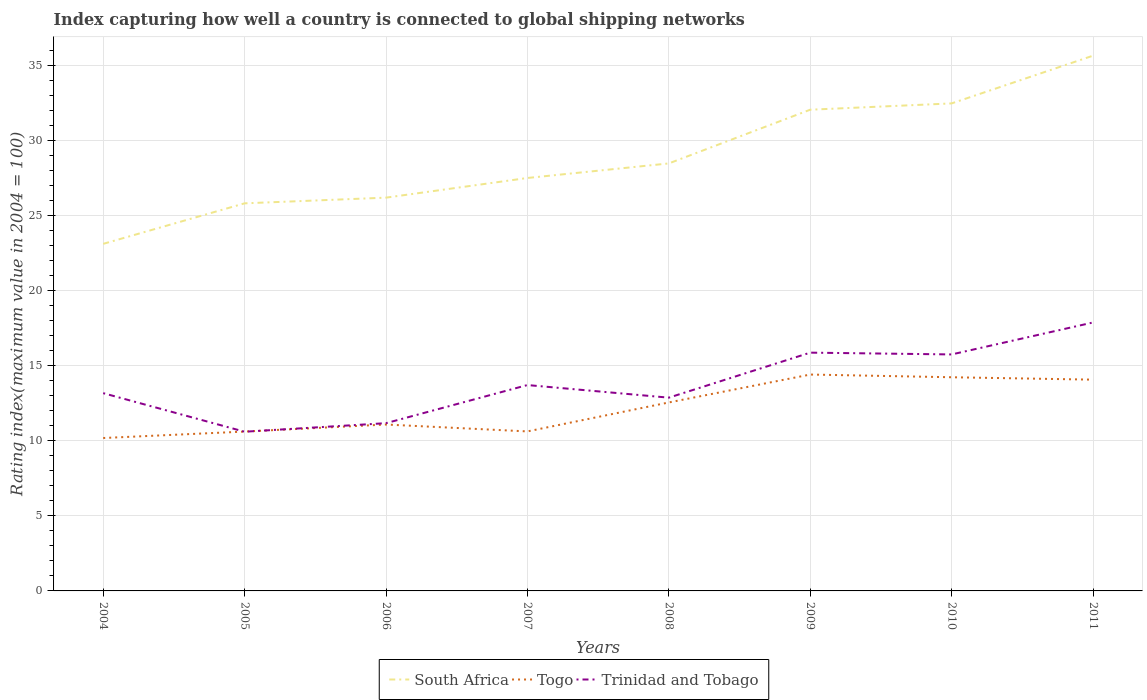How many different coloured lines are there?
Provide a short and direct response. 3. Does the line corresponding to South Africa intersect with the line corresponding to Togo?
Make the answer very short. No. Is the number of lines equal to the number of legend labels?
Your answer should be very brief. Yes. Across all years, what is the maximum rating index in Trinidad and Tobago?
Your response must be concise. 10.61. In which year was the rating index in Togo maximum?
Keep it short and to the point. 2004. What is the total rating index in South Africa in the graph?
Your response must be concise. -4.97. What is the difference between the highest and the second highest rating index in South Africa?
Your response must be concise. 12.54. Is the rating index in Trinidad and Tobago strictly greater than the rating index in Togo over the years?
Offer a very short reply. No. Does the graph contain any zero values?
Provide a short and direct response. No. Where does the legend appear in the graph?
Give a very brief answer. Bottom center. How many legend labels are there?
Offer a very short reply. 3. What is the title of the graph?
Give a very brief answer. Index capturing how well a country is connected to global shipping networks. Does "Upper middle income" appear as one of the legend labels in the graph?
Your answer should be very brief. No. What is the label or title of the X-axis?
Your answer should be very brief. Years. What is the label or title of the Y-axis?
Provide a succinct answer. Rating index(maximum value in 2004 = 100). What is the Rating index(maximum value in 2004 = 100) in South Africa in 2004?
Offer a terse response. 23.13. What is the Rating index(maximum value in 2004 = 100) of Togo in 2004?
Provide a succinct answer. 10.19. What is the Rating index(maximum value in 2004 = 100) of Trinidad and Tobago in 2004?
Your answer should be compact. 13.18. What is the Rating index(maximum value in 2004 = 100) in South Africa in 2005?
Make the answer very short. 25.83. What is the Rating index(maximum value in 2004 = 100) of Togo in 2005?
Offer a terse response. 10.62. What is the Rating index(maximum value in 2004 = 100) of Trinidad and Tobago in 2005?
Your answer should be compact. 10.61. What is the Rating index(maximum value in 2004 = 100) in South Africa in 2006?
Provide a short and direct response. 26.21. What is the Rating index(maximum value in 2004 = 100) of Togo in 2006?
Offer a terse response. 11.09. What is the Rating index(maximum value in 2004 = 100) of Trinidad and Tobago in 2006?
Your response must be concise. 11.18. What is the Rating index(maximum value in 2004 = 100) of South Africa in 2007?
Keep it short and to the point. 27.52. What is the Rating index(maximum value in 2004 = 100) of Togo in 2007?
Your response must be concise. 10.63. What is the Rating index(maximum value in 2004 = 100) of Trinidad and Tobago in 2007?
Your answer should be compact. 13.72. What is the Rating index(maximum value in 2004 = 100) of South Africa in 2008?
Provide a short and direct response. 28.49. What is the Rating index(maximum value in 2004 = 100) in Togo in 2008?
Your answer should be compact. 12.56. What is the Rating index(maximum value in 2004 = 100) of Trinidad and Tobago in 2008?
Give a very brief answer. 12.88. What is the Rating index(maximum value in 2004 = 100) of South Africa in 2009?
Your answer should be very brief. 32.07. What is the Rating index(maximum value in 2004 = 100) of Togo in 2009?
Offer a very short reply. 14.42. What is the Rating index(maximum value in 2004 = 100) in Trinidad and Tobago in 2009?
Your answer should be very brief. 15.88. What is the Rating index(maximum value in 2004 = 100) of South Africa in 2010?
Give a very brief answer. 32.49. What is the Rating index(maximum value in 2004 = 100) of Togo in 2010?
Ensure brevity in your answer.  14.24. What is the Rating index(maximum value in 2004 = 100) in Trinidad and Tobago in 2010?
Ensure brevity in your answer.  15.76. What is the Rating index(maximum value in 2004 = 100) in South Africa in 2011?
Offer a very short reply. 35.67. What is the Rating index(maximum value in 2004 = 100) of Togo in 2011?
Provide a short and direct response. 14.08. What is the Rating index(maximum value in 2004 = 100) of Trinidad and Tobago in 2011?
Offer a terse response. 17.89. Across all years, what is the maximum Rating index(maximum value in 2004 = 100) in South Africa?
Offer a very short reply. 35.67. Across all years, what is the maximum Rating index(maximum value in 2004 = 100) of Togo?
Offer a terse response. 14.42. Across all years, what is the maximum Rating index(maximum value in 2004 = 100) in Trinidad and Tobago?
Keep it short and to the point. 17.89. Across all years, what is the minimum Rating index(maximum value in 2004 = 100) in South Africa?
Offer a terse response. 23.13. Across all years, what is the minimum Rating index(maximum value in 2004 = 100) in Togo?
Make the answer very short. 10.19. Across all years, what is the minimum Rating index(maximum value in 2004 = 100) in Trinidad and Tobago?
Ensure brevity in your answer.  10.61. What is the total Rating index(maximum value in 2004 = 100) in South Africa in the graph?
Your answer should be very brief. 231.41. What is the total Rating index(maximum value in 2004 = 100) in Togo in the graph?
Ensure brevity in your answer.  97.83. What is the total Rating index(maximum value in 2004 = 100) of Trinidad and Tobago in the graph?
Your answer should be very brief. 111.1. What is the difference between the Rating index(maximum value in 2004 = 100) of South Africa in 2004 and that in 2005?
Make the answer very short. -2.7. What is the difference between the Rating index(maximum value in 2004 = 100) in Togo in 2004 and that in 2005?
Your response must be concise. -0.43. What is the difference between the Rating index(maximum value in 2004 = 100) in Trinidad and Tobago in 2004 and that in 2005?
Provide a succinct answer. 2.57. What is the difference between the Rating index(maximum value in 2004 = 100) in South Africa in 2004 and that in 2006?
Provide a succinct answer. -3.08. What is the difference between the Rating index(maximum value in 2004 = 100) in South Africa in 2004 and that in 2007?
Provide a succinct answer. -4.39. What is the difference between the Rating index(maximum value in 2004 = 100) in Togo in 2004 and that in 2007?
Provide a short and direct response. -0.44. What is the difference between the Rating index(maximum value in 2004 = 100) of Trinidad and Tobago in 2004 and that in 2007?
Offer a very short reply. -0.54. What is the difference between the Rating index(maximum value in 2004 = 100) of South Africa in 2004 and that in 2008?
Keep it short and to the point. -5.36. What is the difference between the Rating index(maximum value in 2004 = 100) in Togo in 2004 and that in 2008?
Your response must be concise. -2.37. What is the difference between the Rating index(maximum value in 2004 = 100) in Trinidad and Tobago in 2004 and that in 2008?
Offer a very short reply. 0.3. What is the difference between the Rating index(maximum value in 2004 = 100) of South Africa in 2004 and that in 2009?
Your answer should be compact. -8.94. What is the difference between the Rating index(maximum value in 2004 = 100) in Togo in 2004 and that in 2009?
Your answer should be compact. -4.23. What is the difference between the Rating index(maximum value in 2004 = 100) in South Africa in 2004 and that in 2010?
Provide a succinct answer. -9.36. What is the difference between the Rating index(maximum value in 2004 = 100) in Togo in 2004 and that in 2010?
Offer a very short reply. -4.05. What is the difference between the Rating index(maximum value in 2004 = 100) of Trinidad and Tobago in 2004 and that in 2010?
Give a very brief answer. -2.58. What is the difference between the Rating index(maximum value in 2004 = 100) in South Africa in 2004 and that in 2011?
Provide a succinct answer. -12.54. What is the difference between the Rating index(maximum value in 2004 = 100) in Togo in 2004 and that in 2011?
Offer a terse response. -3.89. What is the difference between the Rating index(maximum value in 2004 = 100) of Trinidad and Tobago in 2004 and that in 2011?
Ensure brevity in your answer.  -4.71. What is the difference between the Rating index(maximum value in 2004 = 100) of South Africa in 2005 and that in 2006?
Keep it short and to the point. -0.38. What is the difference between the Rating index(maximum value in 2004 = 100) in Togo in 2005 and that in 2006?
Keep it short and to the point. -0.47. What is the difference between the Rating index(maximum value in 2004 = 100) of Trinidad and Tobago in 2005 and that in 2006?
Ensure brevity in your answer.  -0.57. What is the difference between the Rating index(maximum value in 2004 = 100) in South Africa in 2005 and that in 2007?
Provide a short and direct response. -1.69. What is the difference between the Rating index(maximum value in 2004 = 100) in Togo in 2005 and that in 2007?
Offer a very short reply. -0.01. What is the difference between the Rating index(maximum value in 2004 = 100) of Trinidad and Tobago in 2005 and that in 2007?
Offer a very short reply. -3.11. What is the difference between the Rating index(maximum value in 2004 = 100) in South Africa in 2005 and that in 2008?
Keep it short and to the point. -2.66. What is the difference between the Rating index(maximum value in 2004 = 100) of Togo in 2005 and that in 2008?
Offer a terse response. -1.94. What is the difference between the Rating index(maximum value in 2004 = 100) in Trinidad and Tobago in 2005 and that in 2008?
Offer a terse response. -2.27. What is the difference between the Rating index(maximum value in 2004 = 100) in South Africa in 2005 and that in 2009?
Make the answer very short. -6.24. What is the difference between the Rating index(maximum value in 2004 = 100) in Trinidad and Tobago in 2005 and that in 2009?
Make the answer very short. -5.27. What is the difference between the Rating index(maximum value in 2004 = 100) of South Africa in 2005 and that in 2010?
Your response must be concise. -6.66. What is the difference between the Rating index(maximum value in 2004 = 100) in Togo in 2005 and that in 2010?
Offer a very short reply. -3.62. What is the difference between the Rating index(maximum value in 2004 = 100) of Trinidad and Tobago in 2005 and that in 2010?
Make the answer very short. -5.15. What is the difference between the Rating index(maximum value in 2004 = 100) in South Africa in 2005 and that in 2011?
Provide a succinct answer. -9.84. What is the difference between the Rating index(maximum value in 2004 = 100) of Togo in 2005 and that in 2011?
Give a very brief answer. -3.46. What is the difference between the Rating index(maximum value in 2004 = 100) of Trinidad and Tobago in 2005 and that in 2011?
Your answer should be very brief. -7.28. What is the difference between the Rating index(maximum value in 2004 = 100) in South Africa in 2006 and that in 2007?
Provide a succinct answer. -1.31. What is the difference between the Rating index(maximum value in 2004 = 100) in Togo in 2006 and that in 2007?
Ensure brevity in your answer.  0.46. What is the difference between the Rating index(maximum value in 2004 = 100) of Trinidad and Tobago in 2006 and that in 2007?
Ensure brevity in your answer.  -2.54. What is the difference between the Rating index(maximum value in 2004 = 100) in South Africa in 2006 and that in 2008?
Offer a very short reply. -2.28. What is the difference between the Rating index(maximum value in 2004 = 100) of Togo in 2006 and that in 2008?
Make the answer very short. -1.47. What is the difference between the Rating index(maximum value in 2004 = 100) in South Africa in 2006 and that in 2009?
Give a very brief answer. -5.86. What is the difference between the Rating index(maximum value in 2004 = 100) of Togo in 2006 and that in 2009?
Your answer should be compact. -3.33. What is the difference between the Rating index(maximum value in 2004 = 100) in South Africa in 2006 and that in 2010?
Your answer should be very brief. -6.28. What is the difference between the Rating index(maximum value in 2004 = 100) in Togo in 2006 and that in 2010?
Your answer should be compact. -3.15. What is the difference between the Rating index(maximum value in 2004 = 100) of Trinidad and Tobago in 2006 and that in 2010?
Keep it short and to the point. -4.58. What is the difference between the Rating index(maximum value in 2004 = 100) in South Africa in 2006 and that in 2011?
Ensure brevity in your answer.  -9.46. What is the difference between the Rating index(maximum value in 2004 = 100) of Togo in 2006 and that in 2011?
Offer a terse response. -2.99. What is the difference between the Rating index(maximum value in 2004 = 100) of Trinidad and Tobago in 2006 and that in 2011?
Give a very brief answer. -6.71. What is the difference between the Rating index(maximum value in 2004 = 100) in South Africa in 2007 and that in 2008?
Ensure brevity in your answer.  -0.97. What is the difference between the Rating index(maximum value in 2004 = 100) of Togo in 2007 and that in 2008?
Ensure brevity in your answer.  -1.93. What is the difference between the Rating index(maximum value in 2004 = 100) of Trinidad and Tobago in 2007 and that in 2008?
Provide a succinct answer. 0.84. What is the difference between the Rating index(maximum value in 2004 = 100) of South Africa in 2007 and that in 2009?
Your response must be concise. -4.55. What is the difference between the Rating index(maximum value in 2004 = 100) of Togo in 2007 and that in 2009?
Your answer should be very brief. -3.79. What is the difference between the Rating index(maximum value in 2004 = 100) in Trinidad and Tobago in 2007 and that in 2009?
Your answer should be very brief. -2.16. What is the difference between the Rating index(maximum value in 2004 = 100) of South Africa in 2007 and that in 2010?
Offer a very short reply. -4.97. What is the difference between the Rating index(maximum value in 2004 = 100) of Togo in 2007 and that in 2010?
Provide a short and direct response. -3.61. What is the difference between the Rating index(maximum value in 2004 = 100) of Trinidad and Tobago in 2007 and that in 2010?
Ensure brevity in your answer.  -2.04. What is the difference between the Rating index(maximum value in 2004 = 100) in South Africa in 2007 and that in 2011?
Give a very brief answer. -8.15. What is the difference between the Rating index(maximum value in 2004 = 100) in Togo in 2007 and that in 2011?
Provide a succinct answer. -3.45. What is the difference between the Rating index(maximum value in 2004 = 100) in Trinidad and Tobago in 2007 and that in 2011?
Provide a succinct answer. -4.17. What is the difference between the Rating index(maximum value in 2004 = 100) in South Africa in 2008 and that in 2009?
Provide a succinct answer. -3.58. What is the difference between the Rating index(maximum value in 2004 = 100) of Togo in 2008 and that in 2009?
Provide a succinct answer. -1.86. What is the difference between the Rating index(maximum value in 2004 = 100) in Trinidad and Tobago in 2008 and that in 2009?
Provide a short and direct response. -3. What is the difference between the Rating index(maximum value in 2004 = 100) in South Africa in 2008 and that in 2010?
Give a very brief answer. -4. What is the difference between the Rating index(maximum value in 2004 = 100) in Togo in 2008 and that in 2010?
Provide a short and direct response. -1.68. What is the difference between the Rating index(maximum value in 2004 = 100) of Trinidad and Tobago in 2008 and that in 2010?
Provide a short and direct response. -2.88. What is the difference between the Rating index(maximum value in 2004 = 100) in South Africa in 2008 and that in 2011?
Keep it short and to the point. -7.18. What is the difference between the Rating index(maximum value in 2004 = 100) of Togo in 2008 and that in 2011?
Keep it short and to the point. -1.52. What is the difference between the Rating index(maximum value in 2004 = 100) of Trinidad and Tobago in 2008 and that in 2011?
Your answer should be very brief. -5.01. What is the difference between the Rating index(maximum value in 2004 = 100) of South Africa in 2009 and that in 2010?
Keep it short and to the point. -0.42. What is the difference between the Rating index(maximum value in 2004 = 100) in Togo in 2009 and that in 2010?
Make the answer very short. 0.18. What is the difference between the Rating index(maximum value in 2004 = 100) of Trinidad and Tobago in 2009 and that in 2010?
Your answer should be very brief. 0.12. What is the difference between the Rating index(maximum value in 2004 = 100) of South Africa in 2009 and that in 2011?
Provide a short and direct response. -3.6. What is the difference between the Rating index(maximum value in 2004 = 100) in Togo in 2009 and that in 2011?
Offer a very short reply. 0.34. What is the difference between the Rating index(maximum value in 2004 = 100) of Trinidad and Tobago in 2009 and that in 2011?
Your response must be concise. -2.01. What is the difference between the Rating index(maximum value in 2004 = 100) in South Africa in 2010 and that in 2011?
Offer a very short reply. -3.18. What is the difference between the Rating index(maximum value in 2004 = 100) of Togo in 2010 and that in 2011?
Offer a very short reply. 0.16. What is the difference between the Rating index(maximum value in 2004 = 100) in Trinidad and Tobago in 2010 and that in 2011?
Offer a very short reply. -2.13. What is the difference between the Rating index(maximum value in 2004 = 100) of South Africa in 2004 and the Rating index(maximum value in 2004 = 100) of Togo in 2005?
Offer a very short reply. 12.51. What is the difference between the Rating index(maximum value in 2004 = 100) in South Africa in 2004 and the Rating index(maximum value in 2004 = 100) in Trinidad and Tobago in 2005?
Give a very brief answer. 12.52. What is the difference between the Rating index(maximum value in 2004 = 100) in Togo in 2004 and the Rating index(maximum value in 2004 = 100) in Trinidad and Tobago in 2005?
Provide a short and direct response. -0.42. What is the difference between the Rating index(maximum value in 2004 = 100) in South Africa in 2004 and the Rating index(maximum value in 2004 = 100) in Togo in 2006?
Provide a succinct answer. 12.04. What is the difference between the Rating index(maximum value in 2004 = 100) of South Africa in 2004 and the Rating index(maximum value in 2004 = 100) of Trinidad and Tobago in 2006?
Offer a terse response. 11.95. What is the difference between the Rating index(maximum value in 2004 = 100) of Togo in 2004 and the Rating index(maximum value in 2004 = 100) of Trinidad and Tobago in 2006?
Keep it short and to the point. -0.99. What is the difference between the Rating index(maximum value in 2004 = 100) of South Africa in 2004 and the Rating index(maximum value in 2004 = 100) of Trinidad and Tobago in 2007?
Your answer should be compact. 9.41. What is the difference between the Rating index(maximum value in 2004 = 100) in Togo in 2004 and the Rating index(maximum value in 2004 = 100) in Trinidad and Tobago in 2007?
Provide a short and direct response. -3.53. What is the difference between the Rating index(maximum value in 2004 = 100) of South Africa in 2004 and the Rating index(maximum value in 2004 = 100) of Togo in 2008?
Your answer should be very brief. 10.57. What is the difference between the Rating index(maximum value in 2004 = 100) in South Africa in 2004 and the Rating index(maximum value in 2004 = 100) in Trinidad and Tobago in 2008?
Ensure brevity in your answer.  10.25. What is the difference between the Rating index(maximum value in 2004 = 100) in Togo in 2004 and the Rating index(maximum value in 2004 = 100) in Trinidad and Tobago in 2008?
Offer a very short reply. -2.69. What is the difference between the Rating index(maximum value in 2004 = 100) of South Africa in 2004 and the Rating index(maximum value in 2004 = 100) of Togo in 2009?
Your answer should be very brief. 8.71. What is the difference between the Rating index(maximum value in 2004 = 100) in South Africa in 2004 and the Rating index(maximum value in 2004 = 100) in Trinidad and Tobago in 2009?
Your response must be concise. 7.25. What is the difference between the Rating index(maximum value in 2004 = 100) in Togo in 2004 and the Rating index(maximum value in 2004 = 100) in Trinidad and Tobago in 2009?
Provide a succinct answer. -5.69. What is the difference between the Rating index(maximum value in 2004 = 100) in South Africa in 2004 and the Rating index(maximum value in 2004 = 100) in Togo in 2010?
Make the answer very short. 8.89. What is the difference between the Rating index(maximum value in 2004 = 100) in South Africa in 2004 and the Rating index(maximum value in 2004 = 100) in Trinidad and Tobago in 2010?
Provide a succinct answer. 7.37. What is the difference between the Rating index(maximum value in 2004 = 100) of Togo in 2004 and the Rating index(maximum value in 2004 = 100) of Trinidad and Tobago in 2010?
Ensure brevity in your answer.  -5.57. What is the difference between the Rating index(maximum value in 2004 = 100) of South Africa in 2004 and the Rating index(maximum value in 2004 = 100) of Togo in 2011?
Ensure brevity in your answer.  9.05. What is the difference between the Rating index(maximum value in 2004 = 100) of South Africa in 2004 and the Rating index(maximum value in 2004 = 100) of Trinidad and Tobago in 2011?
Your response must be concise. 5.24. What is the difference between the Rating index(maximum value in 2004 = 100) of Togo in 2004 and the Rating index(maximum value in 2004 = 100) of Trinidad and Tobago in 2011?
Your response must be concise. -7.7. What is the difference between the Rating index(maximum value in 2004 = 100) of South Africa in 2005 and the Rating index(maximum value in 2004 = 100) of Togo in 2006?
Your response must be concise. 14.74. What is the difference between the Rating index(maximum value in 2004 = 100) of South Africa in 2005 and the Rating index(maximum value in 2004 = 100) of Trinidad and Tobago in 2006?
Your response must be concise. 14.65. What is the difference between the Rating index(maximum value in 2004 = 100) of Togo in 2005 and the Rating index(maximum value in 2004 = 100) of Trinidad and Tobago in 2006?
Offer a terse response. -0.56. What is the difference between the Rating index(maximum value in 2004 = 100) of South Africa in 2005 and the Rating index(maximum value in 2004 = 100) of Togo in 2007?
Ensure brevity in your answer.  15.2. What is the difference between the Rating index(maximum value in 2004 = 100) in South Africa in 2005 and the Rating index(maximum value in 2004 = 100) in Trinidad and Tobago in 2007?
Provide a short and direct response. 12.11. What is the difference between the Rating index(maximum value in 2004 = 100) of South Africa in 2005 and the Rating index(maximum value in 2004 = 100) of Togo in 2008?
Make the answer very short. 13.27. What is the difference between the Rating index(maximum value in 2004 = 100) of South Africa in 2005 and the Rating index(maximum value in 2004 = 100) of Trinidad and Tobago in 2008?
Offer a very short reply. 12.95. What is the difference between the Rating index(maximum value in 2004 = 100) in Togo in 2005 and the Rating index(maximum value in 2004 = 100) in Trinidad and Tobago in 2008?
Keep it short and to the point. -2.26. What is the difference between the Rating index(maximum value in 2004 = 100) in South Africa in 2005 and the Rating index(maximum value in 2004 = 100) in Togo in 2009?
Provide a succinct answer. 11.41. What is the difference between the Rating index(maximum value in 2004 = 100) in South Africa in 2005 and the Rating index(maximum value in 2004 = 100) in Trinidad and Tobago in 2009?
Make the answer very short. 9.95. What is the difference between the Rating index(maximum value in 2004 = 100) in Togo in 2005 and the Rating index(maximum value in 2004 = 100) in Trinidad and Tobago in 2009?
Make the answer very short. -5.26. What is the difference between the Rating index(maximum value in 2004 = 100) in South Africa in 2005 and the Rating index(maximum value in 2004 = 100) in Togo in 2010?
Ensure brevity in your answer.  11.59. What is the difference between the Rating index(maximum value in 2004 = 100) in South Africa in 2005 and the Rating index(maximum value in 2004 = 100) in Trinidad and Tobago in 2010?
Provide a short and direct response. 10.07. What is the difference between the Rating index(maximum value in 2004 = 100) of Togo in 2005 and the Rating index(maximum value in 2004 = 100) of Trinidad and Tobago in 2010?
Give a very brief answer. -5.14. What is the difference between the Rating index(maximum value in 2004 = 100) of South Africa in 2005 and the Rating index(maximum value in 2004 = 100) of Togo in 2011?
Offer a terse response. 11.75. What is the difference between the Rating index(maximum value in 2004 = 100) of South Africa in 2005 and the Rating index(maximum value in 2004 = 100) of Trinidad and Tobago in 2011?
Keep it short and to the point. 7.94. What is the difference between the Rating index(maximum value in 2004 = 100) of Togo in 2005 and the Rating index(maximum value in 2004 = 100) of Trinidad and Tobago in 2011?
Ensure brevity in your answer.  -7.27. What is the difference between the Rating index(maximum value in 2004 = 100) in South Africa in 2006 and the Rating index(maximum value in 2004 = 100) in Togo in 2007?
Your answer should be compact. 15.58. What is the difference between the Rating index(maximum value in 2004 = 100) of South Africa in 2006 and the Rating index(maximum value in 2004 = 100) of Trinidad and Tobago in 2007?
Make the answer very short. 12.49. What is the difference between the Rating index(maximum value in 2004 = 100) of Togo in 2006 and the Rating index(maximum value in 2004 = 100) of Trinidad and Tobago in 2007?
Provide a succinct answer. -2.63. What is the difference between the Rating index(maximum value in 2004 = 100) in South Africa in 2006 and the Rating index(maximum value in 2004 = 100) in Togo in 2008?
Your answer should be compact. 13.65. What is the difference between the Rating index(maximum value in 2004 = 100) in South Africa in 2006 and the Rating index(maximum value in 2004 = 100) in Trinidad and Tobago in 2008?
Your answer should be compact. 13.33. What is the difference between the Rating index(maximum value in 2004 = 100) in Togo in 2006 and the Rating index(maximum value in 2004 = 100) in Trinidad and Tobago in 2008?
Provide a short and direct response. -1.79. What is the difference between the Rating index(maximum value in 2004 = 100) in South Africa in 2006 and the Rating index(maximum value in 2004 = 100) in Togo in 2009?
Make the answer very short. 11.79. What is the difference between the Rating index(maximum value in 2004 = 100) of South Africa in 2006 and the Rating index(maximum value in 2004 = 100) of Trinidad and Tobago in 2009?
Ensure brevity in your answer.  10.33. What is the difference between the Rating index(maximum value in 2004 = 100) in Togo in 2006 and the Rating index(maximum value in 2004 = 100) in Trinidad and Tobago in 2009?
Offer a terse response. -4.79. What is the difference between the Rating index(maximum value in 2004 = 100) of South Africa in 2006 and the Rating index(maximum value in 2004 = 100) of Togo in 2010?
Keep it short and to the point. 11.97. What is the difference between the Rating index(maximum value in 2004 = 100) in South Africa in 2006 and the Rating index(maximum value in 2004 = 100) in Trinidad and Tobago in 2010?
Offer a very short reply. 10.45. What is the difference between the Rating index(maximum value in 2004 = 100) of Togo in 2006 and the Rating index(maximum value in 2004 = 100) of Trinidad and Tobago in 2010?
Give a very brief answer. -4.67. What is the difference between the Rating index(maximum value in 2004 = 100) of South Africa in 2006 and the Rating index(maximum value in 2004 = 100) of Togo in 2011?
Keep it short and to the point. 12.13. What is the difference between the Rating index(maximum value in 2004 = 100) of South Africa in 2006 and the Rating index(maximum value in 2004 = 100) of Trinidad and Tobago in 2011?
Give a very brief answer. 8.32. What is the difference between the Rating index(maximum value in 2004 = 100) of South Africa in 2007 and the Rating index(maximum value in 2004 = 100) of Togo in 2008?
Provide a succinct answer. 14.96. What is the difference between the Rating index(maximum value in 2004 = 100) of South Africa in 2007 and the Rating index(maximum value in 2004 = 100) of Trinidad and Tobago in 2008?
Keep it short and to the point. 14.64. What is the difference between the Rating index(maximum value in 2004 = 100) of Togo in 2007 and the Rating index(maximum value in 2004 = 100) of Trinidad and Tobago in 2008?
Offer a very short reply. -2.25. What is the difference between the Rating index(maximum value in 2004 = 100) in South Africa in 2007 and the Rating index(maximum value in 2004 = 100) in Trinidad and Tobago in 2009?
Your answer should be compact. 11.64. What is the difference between the Rating index(maximum value in 2004 = 100) in Togo in 2007 and the Rating index(maximum value in 2004 = 100) in Trinidad and Tobago in 2009?
Ensure brevity in your answer.  -5.25. What is the difference between the Rating index(maximum value in 2004 = 100) in South Africa in 2007 and the Rating index(maximum value in 2004 = 100) in Togo in 2010?
Your response must be concise. 13.28. What is the difference between the Rating index(maximum value in 2004 = 100) in South Africa in 2007 and the Rating index(maximum value in 2004 = 100) in Trinidad and Tobago in 2010?
Offer a very short reply. 11.76. What is the difference between the Rating index(maximum value in 2004 = 100) in Togo in 2007 and the Rating index(maximum value in 2004 = 100) in Trinidad and Tobago in 2010?
Provide a succinct answer. -5.13. What is the difference between the Rating index(maximum value in 2004 = 100) of South Africa in 2007 and the Rating index(maximum value in 2004 = 100) of Togo in 2011?
Give a very brief answer. 13.44. What is the difference between the Rating index(maximum value in 2004 = 100) of South Africa in 2007 and the Rating index(maximum value in 2004 = 100) of Trinidad and Tobago in 2011?
Your answer should be compact. 9.63. What is the difference between the Rating index(maximum value in 2004 = 100) of Togo in 2007 and the Rating index(maximum value in 2004 = 100) of Trinidad and Tobago in 2011?
Provide a short and direct response. -7.26. What is the difference between the Rating index(maximum value in 2004 = 100) in South Africa in 2008 and the Rating index(maximum value in 2004 = 100) in Togo in 2009?
Make the answer very short. 14.07. What is the difference between the Rating index(maximum value in 2004 = 100) of South Africa in 2008 and the Rating index(maximum value in 2004 = 100) of Trinidad and Tobago in 2009?
Offer a very short reply. 12.61. What is the difference between the Rating index(maximum value in 2004 = 100) in Togo in 2008 and the Rating index(maximum value in 2004 = 100) in Trinidad and Tobago in 2009?
Keep it short and to the point. -3.32. What is the difference between the Rating index(maximum value in 2004 = 100) of South Africa in 2008 and the Rating index(maximum value in 2004 = 100) of Togo in 2010?
Provide a short and direct response. 14.25. What is the difference between the Rating index(maximum value in 2004 = 100) in South Africa in 2008 and the Rating index(maximum value in 2004 = 100) in Trinidad and Tobago in 2010?
Offer a terse response. 12.73. What is the difference between the Rating index(maximum value in 2004 = 100) in Togo in 2008 and the Rating index(maximum value in 2004 = 100) in Trinidad and Tobago in 2010?
Offer a very short reply. -3.2. What is the difference between the Rating index(maximum value in 2004 = 100) of South Africa in 2008 and the Rating index(maximum value in 2004 = 100) of Togo in 2011?
Give a very brief answer. 14.41. What is the difference between the Rating index(maximum value in 2004 = 100) in Togo in 2008 and the Rating index(maximum value in 2004 = 100) in Trinidad and Tobago in 2011?
Your answer should be compact. -5.33. What is the difference between the Rating index(maximum value in 2004 = 100) of South Africa in 2009 and the Rating index(maximum value in 2004 = 100) of Togo in 2010?
Keep it short and to the point. 17.83. What is the difference between the Rating index(maximum value in 2004 = 100) in South Africa in 2009 and the Rating index(maximum value in 2004 = 100) in Trinidad and Tobago in 2010?
Keep it short and to the point. 16.31. What is the difference between the Rating index(maximum value in 2004 = 100) in Togo in 2009 and the Rating index(maximum value in 2004 = 100) in Trinidad and Tobago in 2010?
Your answer should be very brief. -1.34. What is the difference between the Rating index(maximum value in 2004 = 100) of South Africa in 2009 and the Rating index(maximum value in 2004 = 100) of Togo in 2011?
Offer a very short reply. 17.99. What is the difference between the Rating index(maximum value in 2004 = 100) in South Africa in 2009 and the Rating index(maximum value in 2004 = 100) in Trinidad and Tobago in 2011?
Your response must be concise. 14.18. What is the difference between the Rating index(maximum value in 2004 = 100) in Togo in 2009 and the Rating index(maximum value in 2004 = 100) in Trinidad and Tobago in 2011?
Ensure brevity in your answer.  -3.47. What is the difference between the Rating index(maximum value in 2004 = 100) of South Africa in 2010 and the Rating index(maximum value in 2004 = 100) of Togo in 2011?
Ensure brevity in your answer.  18.41. What is the difference between the Rating index(maximum value in 2004 = 100) of South Africa in 2010 and the Rating index(maximum value in 2004 = 100) of Trinidad and Tobago in 2011?
Make the answer very short. 14.6. What is the difference between the Rating index(maximum value in 2004 = 100) in Togo in 2010 and the Rating index(maximum value in 2004 = 100) in Trinidad and Tobago in 2011?
Your response must be concise. -3.65. What is the average Rating index(maximum value in 2004 = 100) in South Africa per year?
Your answer should be compact. 28.93. What is the average Rating index(maximum value in 2004 = 100) in Togo per year?
Your answer should be compact. 12.23. What is the average Rating index(maximum value in 2004 = 100) of Trinidad and Tobago per year?
Make the answer very short. 13.89. In the year 2004, what is the difference between the Rating index(maximum value in 2004 = 100) in South Africa and Rating index(maximum value in 2004 = 100) in Togo?
Offer a very short reply. 12.94. In the year 2004, what is the difference between the Rating index(maximum value in 2004 = 100) in South Africa and Rating index(maximum value in 2004 = 100) in Trinidad and Tobago?
Provide a succinct answer. 9.95. In the year 2004, what is the difference between the Rating index(maximum value in 2004 = 100) in Togo and Rating index(maximum value in 2004 = 100) in Trinidad and Tobago?
Your answer should be compact. -2.99. In the year 2005, what is the difference between the Rating index(maximum value in 2004 = 100) of South Africa and Rating index(maximum value in 2004 = 100) of Togo?
Offer a terse response. 15.21. In the year 2005, what is the difference between the Rating index(maximum value in 2004 = 100) in South Africa and Rating index(maximum value in 2004 = 100) in Trinidad and Tobago?
Offer a very short reply. 15.22. In the year 2006, what is the difference between the Rating index(maximum value in 2004 = 100) of South Africa and Rating index(maximum value in 2004 = 100) of Togo?
Offer a terse response. 15.12. In the year 2006, what is the difference between the Rating index(maximum value in 2004 = 100) in South Africa and Rating index(maximum value in 2004 = 100) in Trinidad and Tobago?
Your response must be concise. 15.03. In the year 2006, what is the difference between the Rating index(maximum value in 2004 = 100) in Togo and Rating index(maximum value in 2004 = 100) in Trinidad and Tobago?
Offer a very short reply. -0.09. In the year 2007, what is the difference between the Rating index(maximum value in 2004 = 100) of South Africa and Rating index(maximum value in 2004 = 100) of Togo?
Your answer should be compact. 16.89. In the year 2007, what is the difference between the Rating index(maximum value in 2004 = 100) of South Africa and Rating index(maximum value in 2004 = 100) of Trinidad and Tobago?
Your response must be concise. 13.8. In the year 2007, what is the difference between the Rating index(maximum value in 2004 = 100) in Togo and Rating index(maximum value in 2004 = 100) in Trinidad and Tobago?
Offer a very short reply. -3.09. In the year 2008, what is the difference between the Rating index(maximum value in 2004 = 100) in South Africa and Rating index(maximum value in 2004 = 100) in Togo?
Keep it short and to the point. 15.93. In the year 2008, what is the difference between the Rating index(maximum value in 2004 = 100) of South Africa and Rating index(maximum value in 2004 = 100) of Trinidad and Tobago?
Make the answer very short. 15.61. In the year 2008, what is the difference between the Rating index(maximum value in 2004 = 100) in Togo and Rating index(maximum value in 2004 = 100) in Trinidad and Tobago?
Ensure brevity in your answer.  -0.32. In the year 2009, what is the difference between the Rating index(maximum value in 2004 = 100) of South Africa and Rating index(maximum value in 2004 = 100) of Togo?
Provide a short and direct response. 17.65. In the year 2009, what is the difference between the Rating index(maximum value in 2004 = 100) of South Africa and Rating index(maximum value in 2004 = 100) of Trinidad and Tobago?
Ensure brevity in your answer.  16.19. In the year 2009, what is the difference between the Rating index(maximum value in 2004 = 100) in Togo and Rating index(maximum value in 2004 = 100) in Trinidad and Tobago?
Offer a terse response. -1.46. In the year 2010, what is the difference between the Rating index(maximum value in 2004 = 100) of South Africa and Rating index(maximum value in 2004 = 100) of Togo?
Offer a very short reply. 18.25. In the year 2010, what is the difference between the Rating index(maximum value in 2004 = 100) of South Africa and Rating index(maximum value in 2004 = 100) of Trinidad and Tobago?
Your answer should be very brief. 16.73. In the year 2010, what is the difference between the Rating index(maximum value in 2004 = 100) in Togo and Rating index(maximum value in 2004 = 100) in Trinidad and Tobago?
Keep it short and to the point. -1.52. In the year 2011, what is the difference between the Rating index(maximum value in 2004 = 100) of South Africa and Rating index(maximum value in 2004 = 100) of Togo?
Keep it short and to the point. 21.59. In the year 2011, what is the difference between the Rating index(maximum value in 2004 = 100) in South Africa and Rating index(maximum value in 2004 = 100) in Trinidad and Tobago?
Offer a terse response. 17.78. In the year 2011, what is the difference between the Rating index(maximum value in 2004 = 100) in Togo and Rating index(maximum value in 2004 = 100) in Trinidad and Tobago?
Your answer should be very brief. -3.81. What is the ratio of the Rating index(maximum value in 2004 = 100) of South Africa in 2004 to that in 2005?
Make the answer very short. 0.9. What is the ratio of the Rating index(maximum value in 2004 = 100) of Togo in 2004 to that in 2005?
Give a very brief answer. 0.96. What is the ratio of the Rating index(maximum value in 2004 = 100) in Trinidad and Tobago in 2004 to that in 2005?
Your response must be concise. 1.24. What is the ratio of the Rating index(maximum value in 2004 = 100) in South Africa in 2004 to that in 2006?
Your answer should be compact. 0.88. What is the ratio of the Rating index(maximum value in 2004 = 100) in Togo in 2004 to that in 2006?
Provide a short and direct response. 0.92. What is the ratio of the Rating index(maximum value in 2004 = 100) of Trinidad and Tobago in 2004 to that in 2006?
Your answer should be very brief. 1.18. What is the ratio of the Rating index(maximum value in 2004 = 100) in South Africa in 2004 to that in 2007?
Make the answer very short. 0.84. What is the ratio of the Rating index(maximum value in 2004 = 100) of Togo in 2004 to that in 2007?
Your answer should be very brief. 0.96. What is the ratio of the Rating index(maximum value in 2004 = 100) of Trinidad and Tobago in 2004 to that in 2007?
Provide a succinct answer. 0.96. What is the ratio of the Rating index(maximum value in 2004 = 100) of South Africa in 2004 to that in 2008?
Your response must be concise. 0.81. What is the ratio of the Rating index(maximum value in 2004 = 100) in Togo in 2004 to that in 2008?
Make the answer very short. 0.81. What is the ratio of the Rating index(maximum value in 2004 = 100) of Trinidad and Tobago in 2004 to that in 2008?
Your answer should be compact. 1.02. What is the ratio of the Rating index(maximum value in 2004 = 100) in South Africa in 2004 to that in 2009?
Your response must be concise. 0.72. What is the ratio of the Rating index(maximum value in 2004 = 100) of Togo in 2004 to that in 2009?
Offer a very short reply. 0.71. What is the ratio of the Rating index(maximum value in 2004 = 100) of Trinidad and Tobago in 2004 to that in 2009?
Offer a terse response. 0.83. What is the ratio of the Rating index(maximum value in 2004 = 100) of South Africa in 2004 to that in 2010?
Your answer should be compact. 0.71. What is the ratio of the Rating index(maximum value in 2004 = 100) of Togo in 2004 to that in 2010?
Keep it short and to the point. 0.72. What is the ratio of the Rating index(maximum value in 2004 = 100) of Trinidad and Tobago in 2004 to that in 2010?
Your response must be concise. 0.84. What is the ratio of the Rating index(maximum value in 2004 = 100) in South Africa in 2004 to that in 2011?
Your answer should be compact. 0.65. What is the ratio of the Rating index(maximum value in 2004 = 100) of Togo in 2004 to that in 2011?
Ensure brevity in your answer.  0.72. What is the ratio of the Rating index(maximum value in 2004 = 100) of Trinidad and Tobago in 2004 to that in 2011?
Your response must be concise. 0.74. What is the ratio of the Rating index(maximum value in 2004 = 100) of South Africa in 2005 to that in 2006?
Make the answer very short. 0.99. What is the ratio of the Rating index(maximum value in 2004 = 100) in Togo in 2005 to that in 2006?
Your answer should be compact. 0.96. What is the ratio of the Rating index(maximum value in 2004 = 100) of Trinidad and Tobago in 2005 to that in 2006?
Make the answer very short. 0.95. What is the ratio of the Rating index(maximum value in 2004 = 100) in South Africa in 2005 to that in 2007?
Provide a short and direct response. 0.94. What is the ratio of the Rating index(maximum value in 2004 = 100) of Togo in 2005 to that in 2007?
Offer a very short reply. 1. What is the ratio of the Rating index(maximum value in 2004 = 100) of Trinidad and Tobago in 2005 to that in 2007?
Offer a very short reply. 0.77. What is the ratio of the Rating index(maximum value in 2004 = 100) in South Africa in 2005 to that in 2008?
Your answer should be compact. 0.91. What is the ratio of the Rating index(maximum value in 2004 = 100) in Togo in 2005 to that in 2008?
Ensure brevity in your answer.  0.85. What is the ratio of the Rating index(maximum value in 2004 = 100) of Trinidad and Tobago in 2005 to that in 2008?
Make the answer very short. 0.82. What is the ratio of the Rating index(maximum value in 2004 = 100) in South Africa in 2005 to that in 2009?
Keep it short and to the point. 0.81. What is the ratio of the Rating index(maximum value in 2004 = 100) in Togo in 2005 to that in 2009?
Offer a terse response. 0.74. What is the ratio of the Rating index(maximum value in 2004 = 100) of Trinidad and Tobago in 2005 to that in 2009?
Provide a short and direct response. 0.67. What is the ratio of the Rating index(maximum value in 2004 = 100) of South Africa in 2005 to that in 2010?
Your answer should be very brief. 0.8. What is the ratio of the Rating index(maximum value in 2004 = 100) in Togo in 2005 to that in 2010?
Offer a very short reply. 0.75. What is the ratio of the Rating index(maximum value in 2004 = 100) in Trinidad and Tobago in 2005 to that in 2010?
Provide a succinct answer. 0.67. What is the ratio of the Rating index(maximum value in 2004 = 100) of South Africa in 2005 to that in 2011?
Your answer should be very brief. 0.72. What is the ratio of the Rating index(maximum value in 2004 = 100) in Togo in 2005 to that in 2011?
Your response must be concise. 0.75. What is the ratio of the Rating index(maximum value in 2004 = 100) in Trinidad and Tobago in 2005 to that in 2011?
Offer a terse response. 0.59. What is the ratio of the Rating index(maximum value in 2004 = 100) in South Africa in 2006 to that in 2007?
Your answer should be compact. 0.95. What is the ratio of the Rating index(maximum value in 2004 = 100) in Togo in 2006 to that in 2007?
Ensure brevity in your answer.  1.04. What is the ratio of the Rating index(maximum value in 2004 = 100) in Trinidad and Tobago in 2006 to that in 2007?
Your answer should be compact. 0.81. What is the ratio of the Rating index(maximum value in 2004 = 100) of South Africa in 2006 to that in 2008?
Ensure brevity in your answer.  0.92. What is the ratio of the Rating index(maximum value in 2004 = 100) in Togo in 2006 to that in 2008?
Your response must be concise. 0.88. What is the ratio of the Rating index(maximum value in 2004 = 100) in Trinidad and Tobago in 2006 to that in 2008?
Make the answer very short. 0.87. What is the ratio of the Rating index(maximum value in 2004 = 100) of South Africa in 2006 to that in 2009?
Provide a short and direct response. 0.82. What is the ratio of the Rating index(maximum value in 2004 = 100) of Togo in 2006 to that in 2009?
Offer a very short reply. 0.77. What is the ratio of the Rating index(maximum value in 2004 = 100) of Trinidad and Tobago in 2006 to that in 2009?
Keep it short and to the point. 0.7. What is the ratio of the Rating index(maximum value in 2004 = 100) of South Africa in 2006 to that in 2010?
Provide a short and direct response. 0.81. What is the ratio of the Rating index(maximum value in 2004 = 100) of Togo in 2006 to that in 2010?
Give a very brief answer. 0.78. What is the ratio of the Rating index(maximum value in 2004 = 100) of Trinidad and Tobago in 2006 to that in 2010?
Make the answer very short. 0.71. What is the ratio of the Rating index(maximum value in 2004 = 100) of South Africa in 2006 to that in 2011?
Provide a short and direct response. 0.73. What is the ratio of the Rating index(maximum value in 2004 = 100) of Togo in 2006 to that in 2011?
Your response must be concise. 0.79. What is the ratio of the Rating index(maximum value in 2004 = 100) in Trinidad and Tobago in 2006 to that in 2011?
Your answer should be compact. 0.62. What is the ratio of the Rating index(maximum value in 2004 = 100) in Togo in 2007 to that in 2008?
Provide a short and direct response. 0.85. What is the ratio of the Rating index(maximum value in 2004 = 100) of Trinidad and Tobago in 2007 to that in 2008?
Ensure brevity in your answer.  1.07. What is the ratio of the Rating index(maximum value in 2004 = 100) in South Africa in 2007 to that in 2009?
Ensure brevity in your answer.  0.86. What is the ratio of the Rating index(maximum value in 2004 = 100) in Togo in 2007 to that in 2009?
Offer a terse response. 0.74. What is the ratio of the Rating index(maximum value in 2004 = 100) of Trinidad and Tobago in 2007 to that in 2009?
Make the answer very short. 0.86. What is the ratio of the Rating index(maximum value in 2004 = 100) of South Africa in 2007 to that in 2010?
Make the answer very short. 0.85. What is the ratio of the Rating index(maximum value in 2004 = 100) in Togo in 2007 to that in 2010?
Give a very brief answer. 0.75. What is the ratio of the Rating index(maximum value in 2004 = 100) of Trinidad and Tobago in 2007 to that in 2010?
Your answer should be very brief. 0.87. What is the ratio of the Rating index(maximum value in 2004 = 100) of South Africa in 2007 to that in 2011?
Your answer should be very brief. 0.77. What is the ratio of the Rating index(maximum value in 2004 = 100) in Togo in 2007 to that in 2011?
Give a very brief answer. 0.76. What is the ratio of the Rating index(maximum value in 2004 = 100) in Trinidad and Tobago in 2007 to that in 2011?
Provide a succinct answer. 0.77. What is the ratio of the Rating index(maximum value in 2004 = 100) of South Africa in 2008 to that in 2009?
Provide a short and direct response. 0.89. What is the ratio of the Rating index(maximum value in 2004 = 100) of Togo in 2008 to that in 2009?
Your answer should be compact. 0.87. What is the ratio of the Rating index(maximum value in 2004 = 100) of Trinidad and Tobago in 2008 to that in 2009?
Your response must be concise. 0.81. What is the ratio of the Rating index(maximum value in 2004 = 100) in South Africa in 2008 to that in 2010?
Your answer should be compact. 0.88. What is the ratio of the Rating index(maximum value in 2004 = 100) of Togo in 2008 to that in 2010?
Your answer should be compact. 0.88. What is the ratio of the Rating index(maximum value in 2004 = 100) in Trinidad and Tobago in 2008 to that in 2010?
Ensure brevity in your answer.  0.82. What is the ratio of the Rating index(maximum value in 2004 = 100) in South Africa in 2008 to that in 2011?
Your answer should be very brief. 0.8. What is the ratio of the Rating index(maximum value in 2004 = 100) of Togo in 2008 to that in 2011?
Give a very brief answer. 0.89. What is the ratio of the Rating index(maximum value in 2004 = 100) of Trinidad and Tobago in 2008 to that in 2011?
Make the answer very short. 0.72. What is the ratio of the Rating index(maximum value in 2004 = 100) in South Africa in 2009 to that in 2010?
Give a very brief answer. 0.99. What is the ratio of the Rating index(maximum value in 2004 = 100) of Togo in 2009 to that in 2010?
Ensure brevity in your answer.  1.01. What is the ratio of the Rating index(maximum value in 2004 = 100) of Trinidad and Tobago in 2009 to that in 2010?
Provide a succinct answer. 1.01. What is the ratio of the Rating index(maximum value in 2004 = 100) in South Africa in 2009 to that in 2011?
Ensure brevity in your answer.  0.9. What is the ratio of the Rating index(maximum value in 2004 = 100) of Togo in 2009 to that in 2011?
Your answer should be compact. 1.02. What is the ratio of the Rating index(maximum value in 2004 = 100) in Trinidad and Tobago in 2009 to that in 2011?
Offer a very short reply. 0.89. What is the ratio of the Rating index(maximum value in 2004 = 100) of South Africa in 2010 to that in 2011?
Ensure brevity in your answer.  0.91. What is the ratio of the Rating index(maximum value in 2004 = 100) of Togo in 2010 to that in 2011?
Offer a terse response. 1.01. What is the ratio of the Rating index(maximum value in 2004 = 100) of Trinidad and Tobago in 2010 to that in 2011?
Offer a terse response. 0.88. What is the difference between the highest and the second highest Rating index(maximum value in 2004 = 100) of South Africa?
Make the answer very short. 3.18. What is the difference between the highest and the second highest Rating index(maximum value in 2004 = 100) of Togo?
Your response must be concise. 0.18. What is the difference between the highest and the second highest Rating index(maximum value in 2004 = 100) of Trinidad and Tobago?
Offer a terse response. 2.01. What is the difference between the highest and the lowest Rating index(maximum value in 2004 = 100) in South Africa?
Provide a short and direct response. 12.54. What is the difference between the highest and the lowest Rating index(maximum value in 2004 = 100) in Togo?
Your answer should be very brief. 4.23. What is the difference between the highest and the lowest Rating index(maximum value in 2004 = 100) in Trinidad and Tobago?
Your response must be concise. 7.28. 